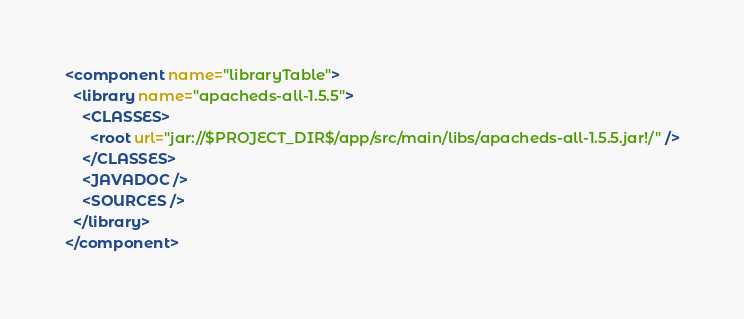<code> <loc_0><loc_0><loc_500><loc_500><_XML_><component name="libraryTable">
  <library name="apacheds-all-1.5.5">
    <CLASSES>
      <root url="jar://$PROJECT_DIR$/app/src/main/libs/apacheds-all-1.5.5.jar!/" />
    </CLASSES>
    <JAVADOC />
    <SOURCES />
  </library>
</component></code> 